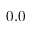Convert formula to latex. <formula><loc_0><loc_0><loc_500><loc_500>0 . 0</formula> 